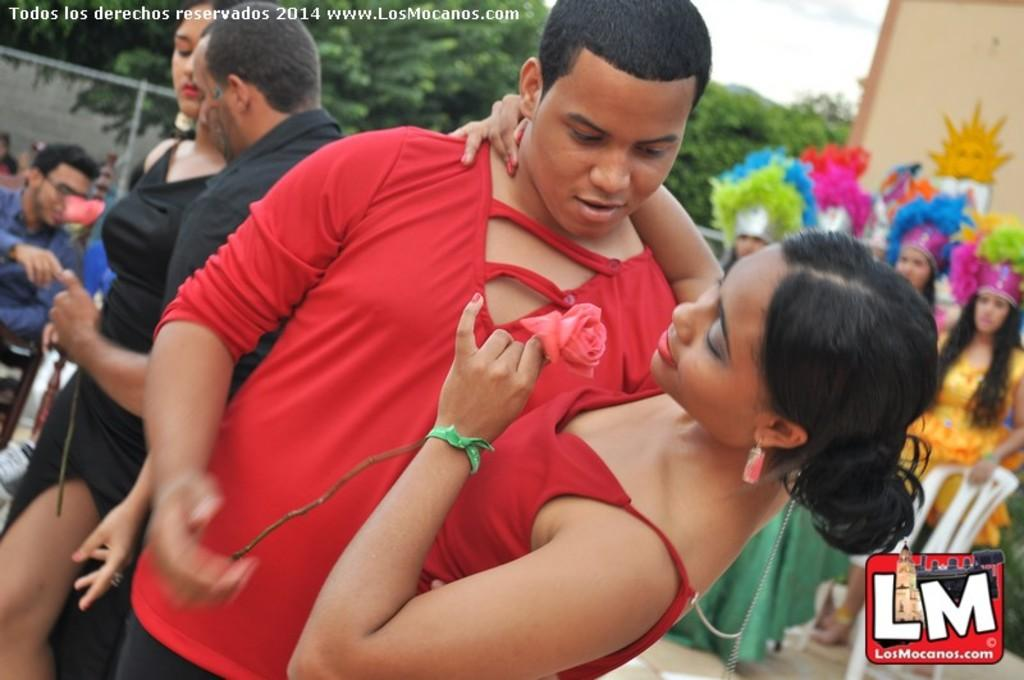What are the people in the image doing? The people in the image are standing on the road. Can you describe the appearance of some of the people in the image? Some of the people are wearing costumes. What can be seen in the background of the image? The sky, clouds, trees, and a building can be seen in the background of the image. What type of leather is being used to make the army uniforms in the image? There is no army or leather present in the image; it features people standing on the road, some of whom are wearing costumes. 